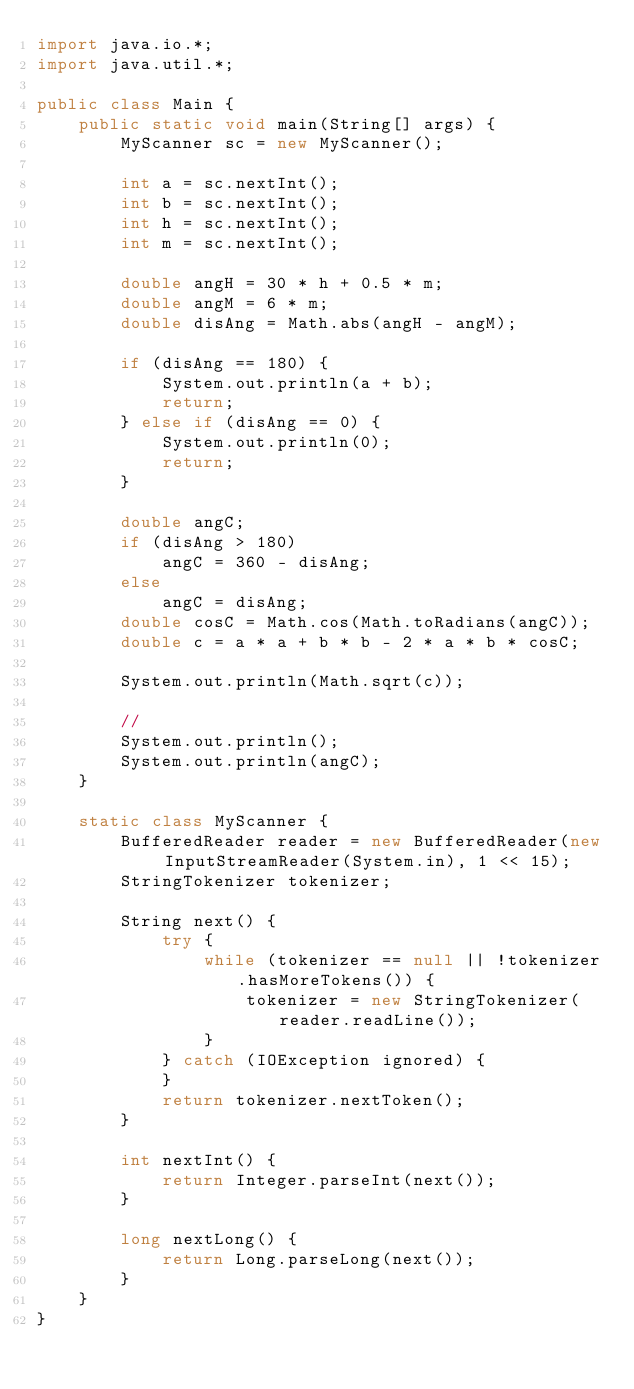<code> <loc_0><loc_0><loc_500><loc_500><_Java_>import java.io.*;
import java.util.*;

public class Main {
    public static void main(String[] args) {
        MyScanner sc = new MyScanner();

        int a = sc.nextInt();
        int b = sc.nextInt();
        int h = sc.nextInt();
        int m = sc.nextInt();

        double angH = 30 * h + 0.5 * m;
        double angM = 6 * m;
        double disAng = Math.abs(angH - angM);

        if (disAng == 180) {
            System.out.println(a + b);
            return;
        } else if (disAng == 0) {
            System.out.println(0);
            return;
        }

        double angC;
        if (disAng > 180)
            angC = 360 - disAng;
        else
            angC = disAng;
        double cosC = Math.cos(Math.toRadians(angC));
        double c = a * a + b * b - 2 * a * b * cosC;

        System.out.println(Math.sqrt(c));

        //
        System.out.println();
        System.out.println(angC);
    }

    static class MyScanner {
        BufferedReader reader = new BufferedReader(new InputStreamReader(System.in), 1 << 15);
        StringTokenizer tokenizer;

        String next() {
            try {
                while (tokenizer == null || !tokenizer.hasMoreTokens()) {
                    tokenizer = new StringTokenizer(reader.readLine());
                }
            } catch (IOException ignored) {
            }
            return tokenizer.nextToken();
        }

        int nextInt() {
            return Integer.parseInt(next());
        }

        long nextLong() {
            return Long.parseLong(next());
        }
    }
}</code> 